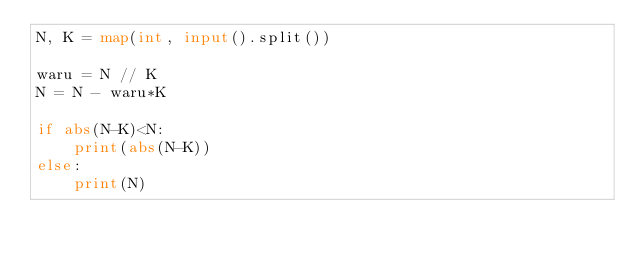<code> <loc_0><loc_0><loc_500><loc_500><_Python_>N, K = map(int, input().split())

waru = N // K
N = N - waru*K

if abs(N-K)<N:
    print(abs(N-K))
else:
    print(N)</code> 